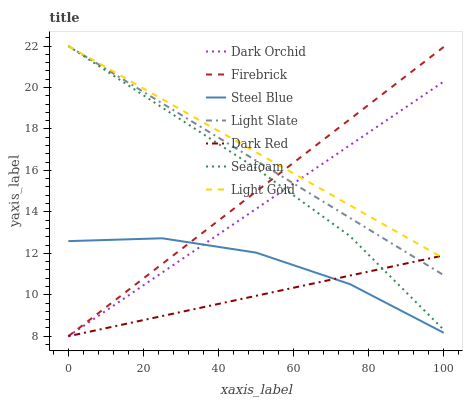Does Dark Red have the minimum area under the curve?
Answer yes or no. Yes. Does Light Gold have the maximum area under the curve?
Answer yes or no. Yes. Does Firebrick have the minimum area under the curve?
Answer yes or no. No. Does Firebrick have the maximum area under the curve?
Answer yes or no. No. Is Light Gold the smoothest?
Answer yes or no. Yes. Is Steel Blue the roughest?
Answer yes or no. Yes. Is Dark Red the smoothest?
Answer yes or no. No. Is Dark Red the roughest?
Answer yes or no. No. Does Dark Red have the lowest value?
Answer yes or no. Yes. Does Steel Blue have the lowest value?
Answer yes or no. No. Does Light Gold have the highest value?
Answer yes or no. Yes. Does Firebrick have the highest value?
Answer yes or no. No. Is Steel Blue less than Light Gold?
Answer yes or no. Yes. Is Seafoam greater than Steel Blue?
Answer yes or no. Yes. Does Seafoam intersect Dark Orchid?
Answer yes or no. Yes. Is Seafoam less than Dark Orchid?
Answer yes or no. No. Is Seafoam greater than Dark Orchid?
Answer yes or no. No. Does Steel Blue intersect Light Gold?
Answer yes or no. No. 